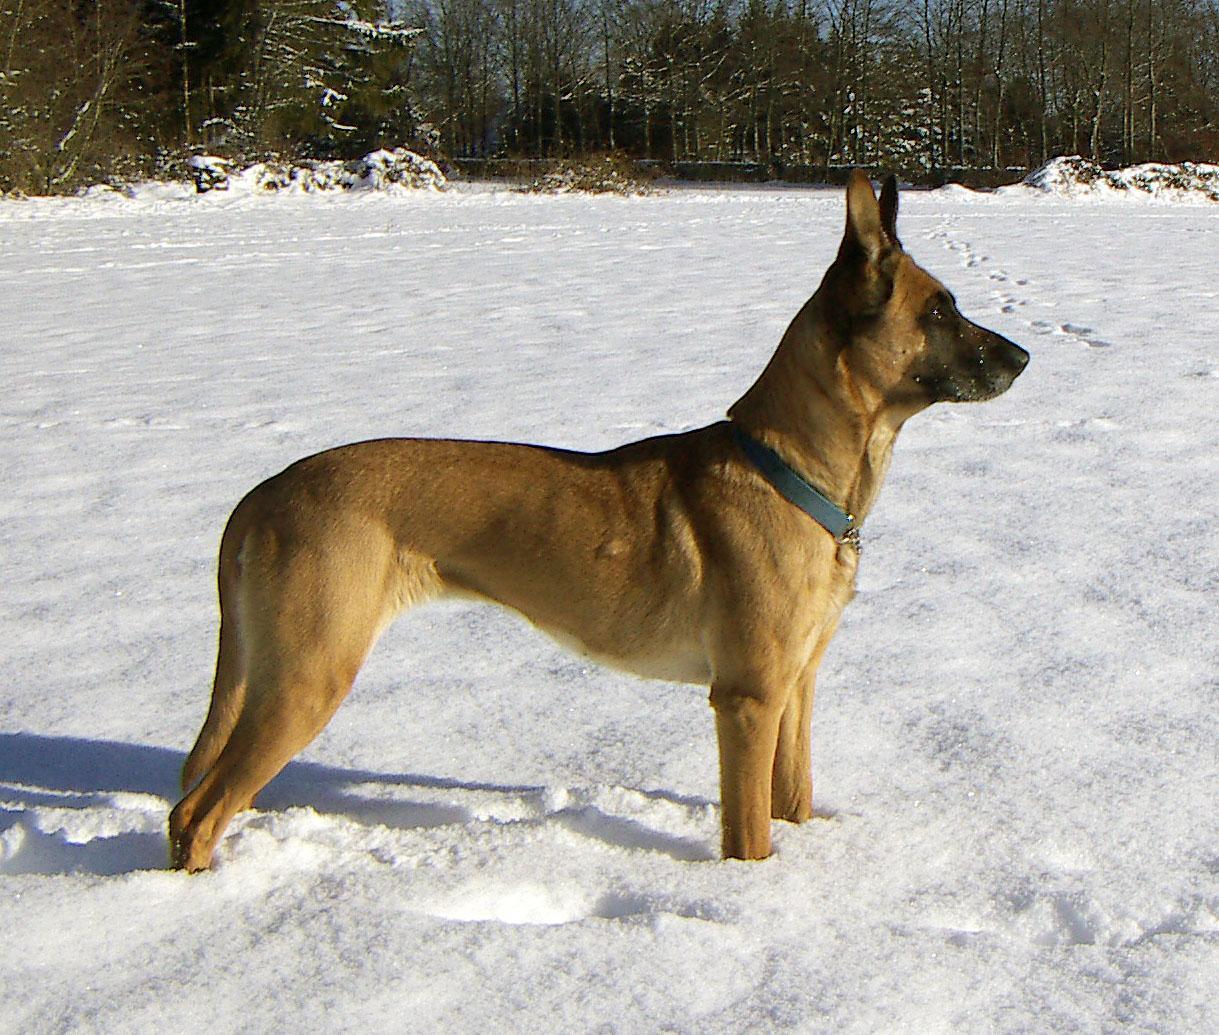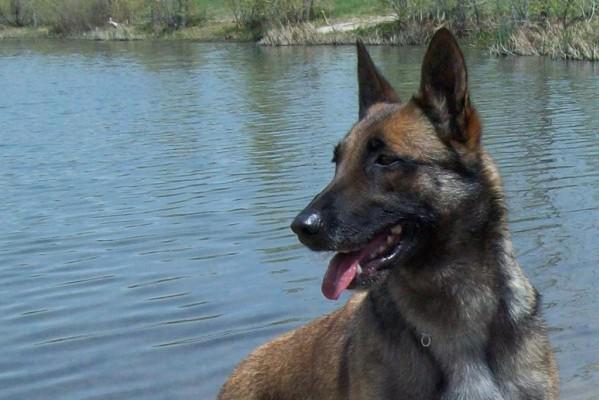The first image is the image on the left, the second image is the image on the right. For the images displayed, is the sentence "There are two dogs shown." factually correct? Answer yes or no. Yes. The first image is the image on the left, the second image is the image on the right. Given the left and right images, does the statement "The left photo shows a dog on top of a rock." hold true? Answer yes or no. No. 